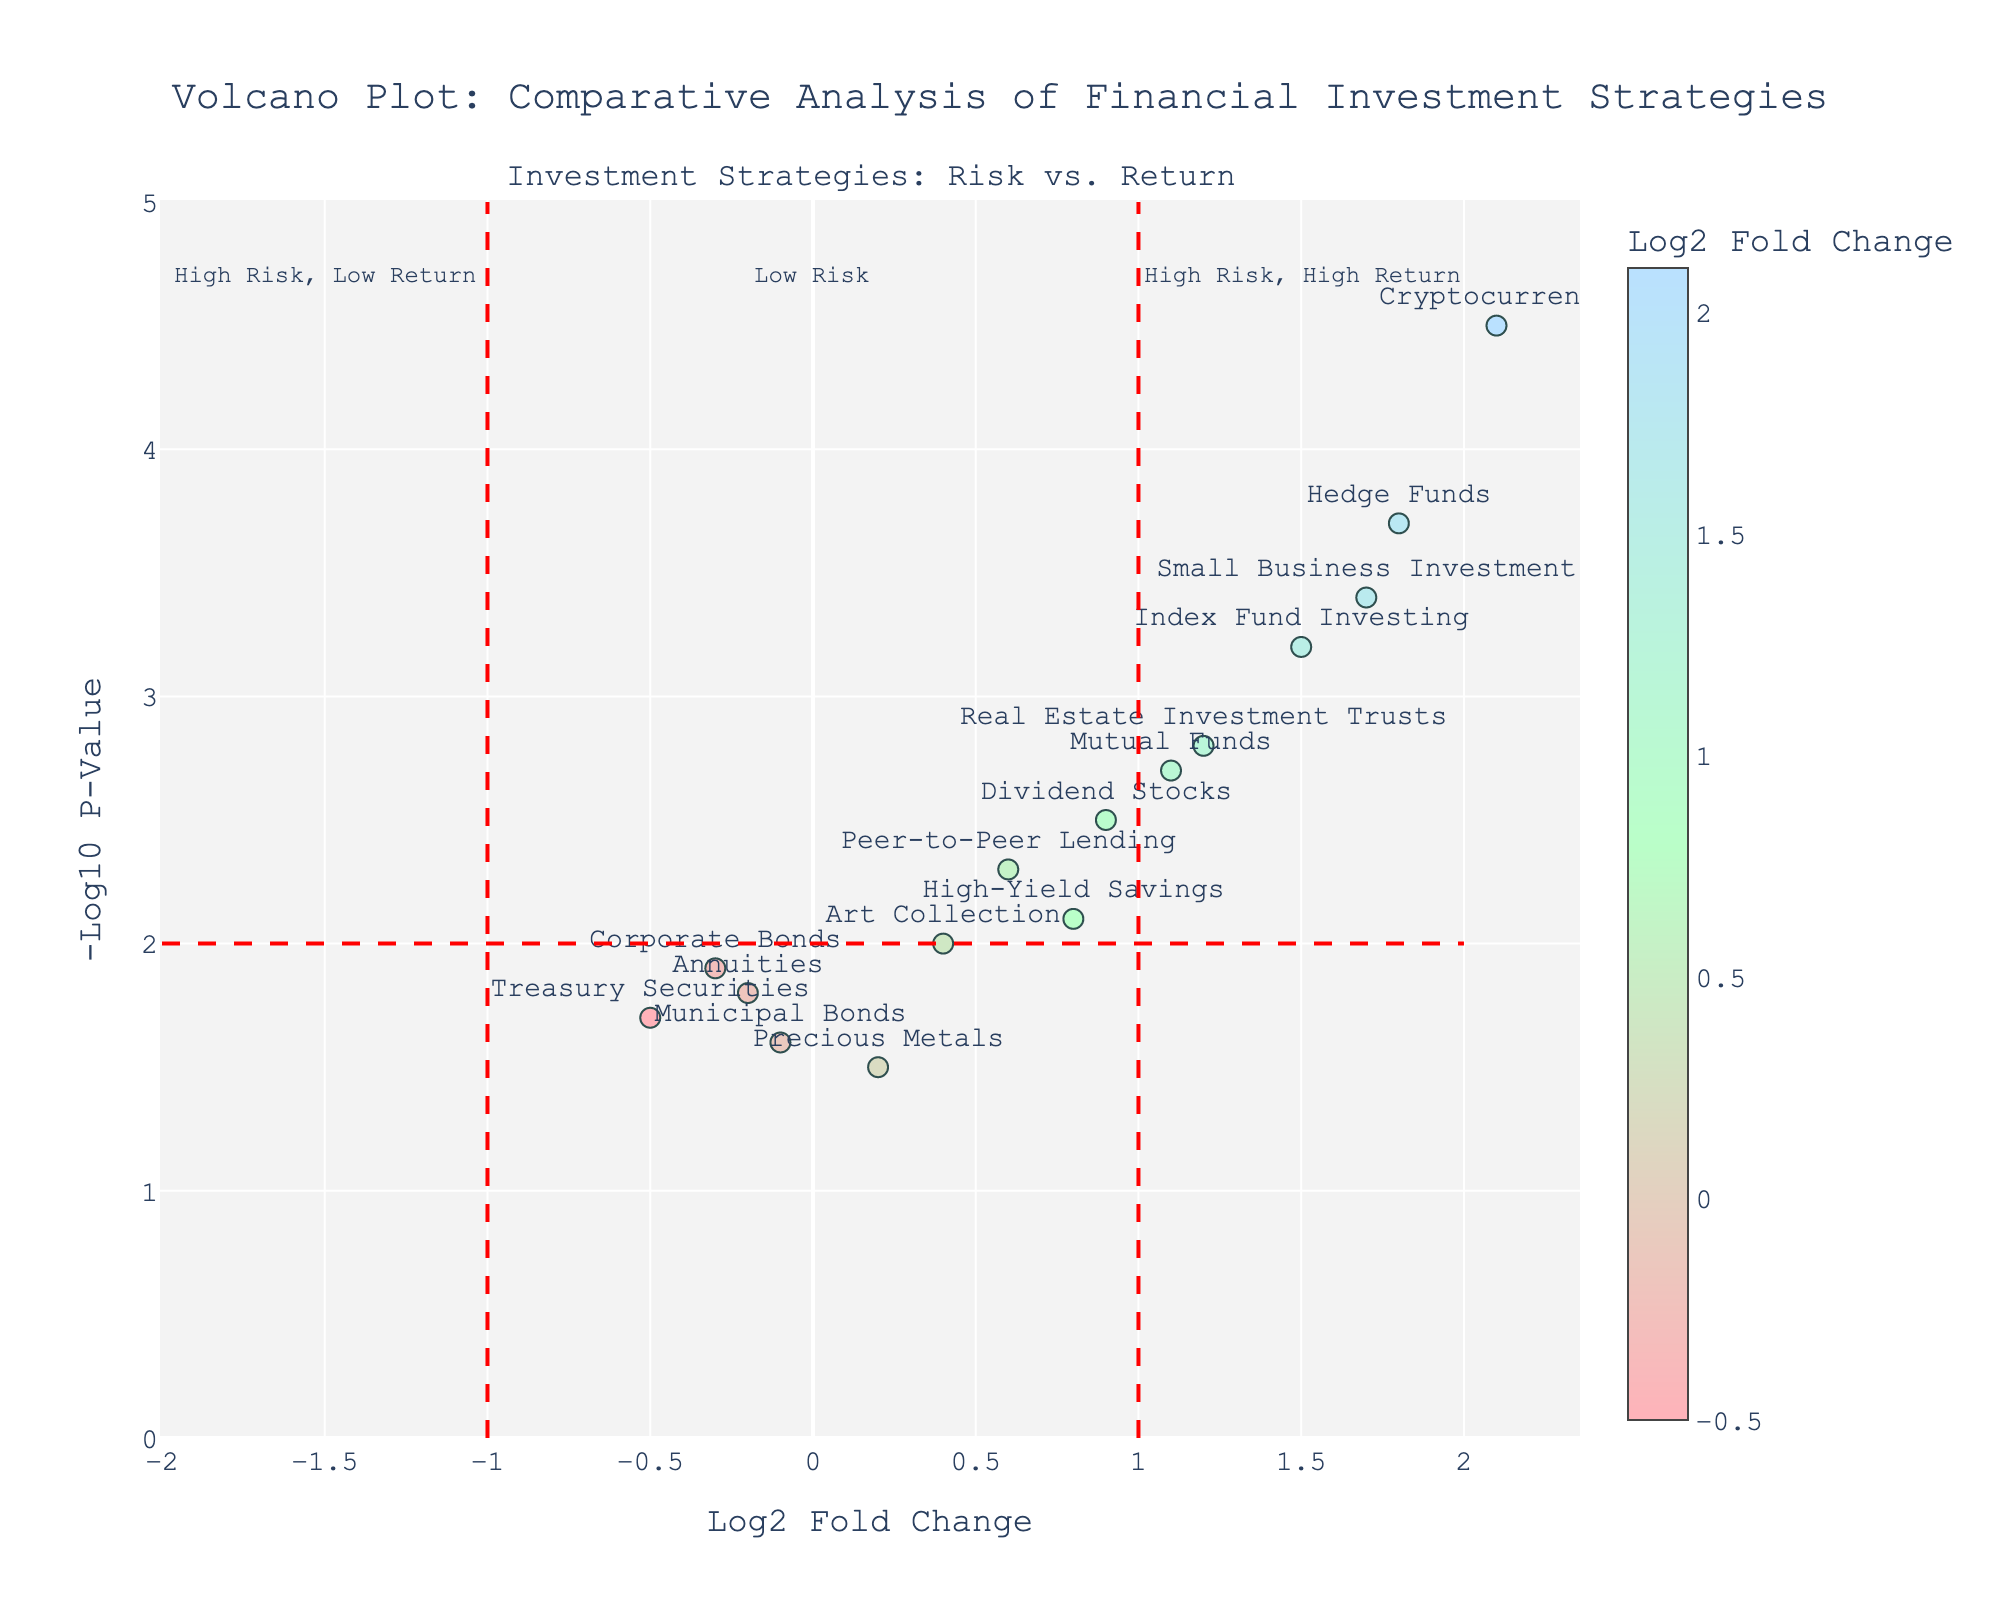What is the title of the figure? The title of the figure is visible at the top and is bolded to stand out. It reads "Volcano Plot: Comparative Analysis of Financial Investment Strategies".
Answer: Volcano Plot: Comparative Analysis of Financial Investment Strategies Which strategy has the highest Log2 Fold Change? By examining the horizontal axis labeled "Log2 Fold Change", the strategy that appears furthest to the right has the highest value. This strategy is Cryptocurrency.
Answer: Cryptocurrency How many strategies have negative Log2 Fold Change values? Counting data points on the left side of the vertical axis (Log2 Fold Change < 0), we find three strategies with negative values: Corporate Bonds, Treasury Securities, and Municipal Bonds.
Answer: 3 What does a point at x = 0 and y = 0 represent? x = 0 and y = 0 would signify a Log2 Fold Change of 0 and a -Log10 P-Value of 0, meaning no change in returns and a p-value of 1, indicative of no statistical significance.
Answer: No change and no statistical significance Which investment strategy is closest to having a Log2 Fold Change of 1.0 and a -Log10 P-Value of 2.7? Based on the plot positions, Mutual Funds is the strategy closest to the coordinates (1.0, 2.7).
Answer: Mutual Funds Which strategy has the highest -Log10 P-Value and what is its Log2 Fold Change? By looking at the vertical axis and finding the highest point, Cryptocurrency has the highest -Log10 P-Value of 4.5. Its Log2 Fold Change is 2.1.
Answer: Cryptocurrency, 2.1 Compare Index Fund Investing and Hedge Funds in terms of Log2 Fold Change and -Log10 P-Value. Which has higher risk and return? Comparing their positions, Index Fund Investing shows a Log2 Fold Change of 1.5 and a -Log10 P-Value of 3.2, while Hedge Funds has 1.8 and 3.7 respectively. Hedge Funds have both higher risk and potential return based on these metrics.
Answer: Hedge Funds Are there more strategies classified under high or low risk according to the plot annotations? High risk is indicated by regions beyond ±1 on Log2 Fold Change. Counting data points in these regions, there are more strategies classified as high risk (Cryptocurrency, Hedge Funds, Small Business Investment, Index Fund Investing) than low risk.
Answer: High risk What annotation explains the region where most strategies fall? The plot shows most data points lie near the center, within the boundaries of ±1 Log2 Fold Change. The annotation "Low Risk" above these points explains this region.
Answer: Low Risk 